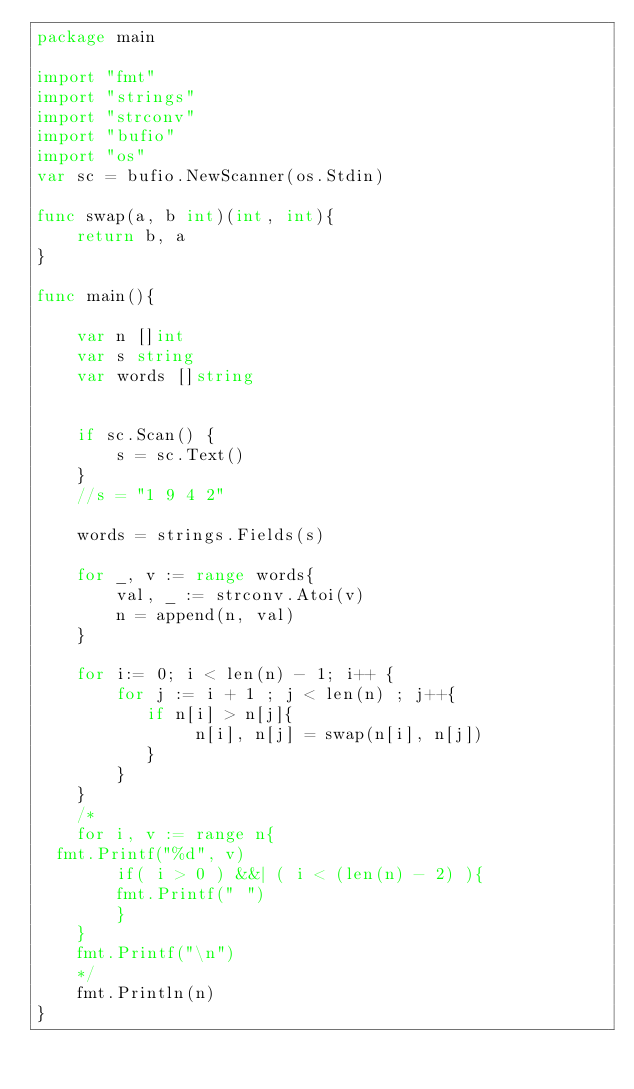<code> <loc_0><loc_0><loc_500><loc_500><_Go_>package main

import "fmt"
import "strings"
import "strconv"
import "bufio"
import "os"
var sc = bufio.NewScanner(os.Stdin)

func swap(a, b int)(int, int){
    return b, a 
}

func main(){

    var n []int
    var s string
    var words []string
    
    
    if sc.Scan() {
        s = sc.Text()
    }
    //s = "1 9 4 2"    

    words = strings.Fields(s) 

    for _, v := range words{
        val, _ := strconv.Atoi(v) 
        n = append(n, val) 
    }
 
    for i:= 0; i < len(n) - 1; i++ {
        for j := i + 1 ; j < len(n) ; j++{
           if n[i] > n[j]{
                n[i], n[j] = swap(n[i], n[j])
           }
        }
    } 
    /*
    for i, v := range n{
	fmt.Printf("%d", v)
        if( i > 0 ) &&| ( i < (len(n) - 2) ){
        fmt.Printf(" ")
        }
    }
    fmt.Printf("\n")
    */
    fmt.Println(n)
}
</code> 